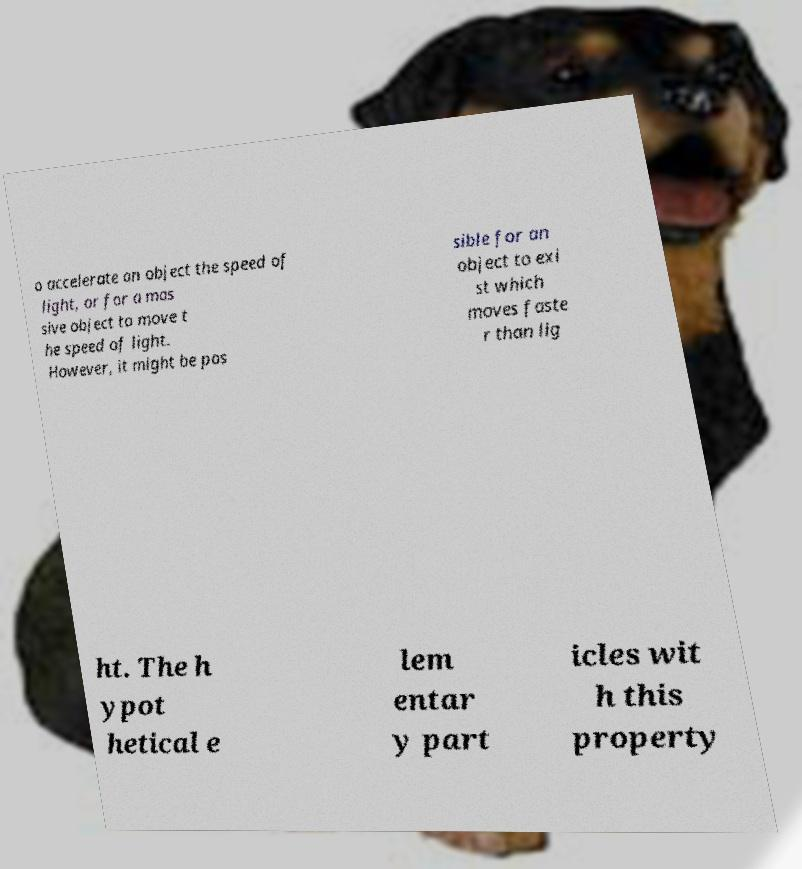Could you assist in decoding the text presented in this image and type it out clearly? o accelerate an object the speed of light, or for a mas sive object to move t he speed of light. However, it might be pos sible for an object to exi st which moves faste r than lig ht. The h ypot hetical e lem entar y part icles wit h this property 